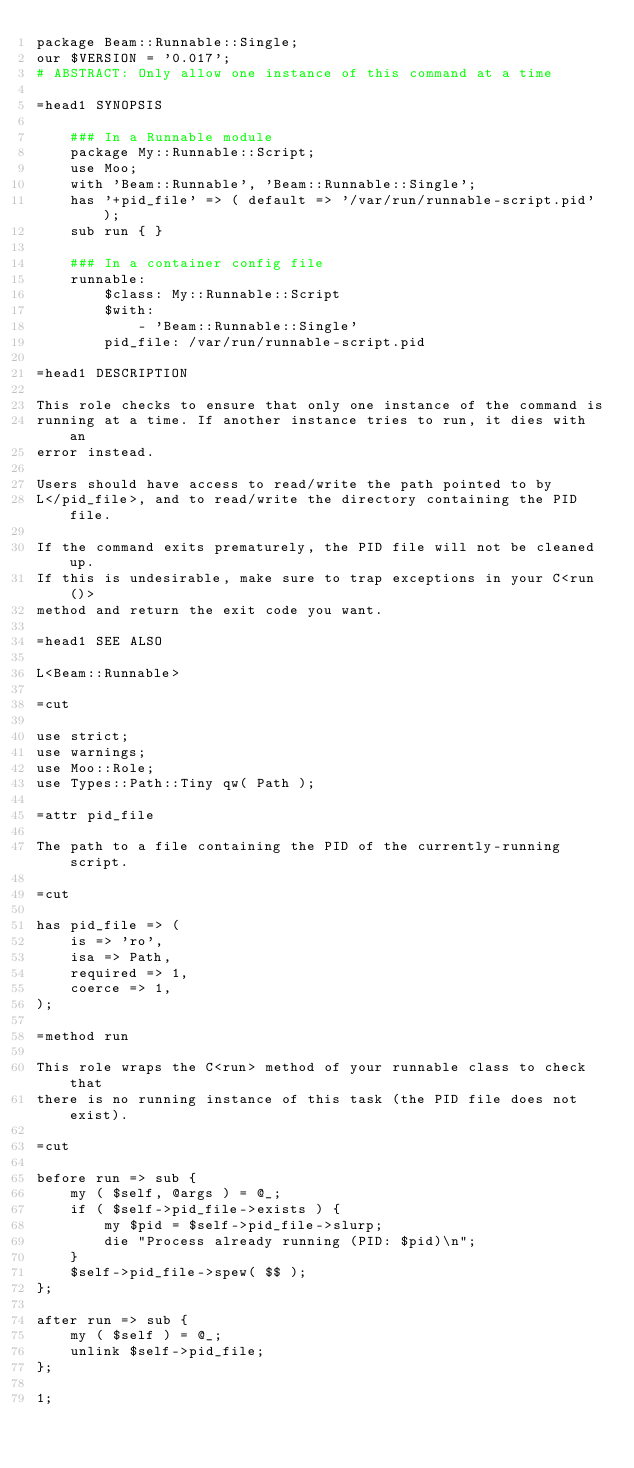Convert code to text. <code><loc_0><loc_0><loc_500><loc_500><_Perl_>package Beam::Runnable::Single;
our $VERSION = '0.017';
# ABSTRACT: Only allow one instance of this command at a time

=head1 SYNOPSIS

    ### In a Runnable module
    package My::Runnable::Script;
    use Moo;
    with 'Beam::Runnable', 'Beam::Runnable::Single';
    has '+pid_file' => ( default => '/var/run/runnable-script.pid' );
    sub run { }

    ### In a container config file
    runnable:
        $class: My::Runnable::Script
        $with:
            - 'Beam::Runnable::Single'
        pid_file: /var/run/runnable-script.pid

=head1 DESCRIPTION

This role checks to ensure that only one instance of the command is
running at a time. If another instance tries to run, it dies with an
error instead.

Users should have access to read/write the path pointed to by
L</pid_file>, and to read/write the directory containing the PID file.

If the command exits prematurely, the PID file will not be cleaned up.
If this is undesirable, make sure to trap exceptions in your C<run()>
method and return the exit code you want.

=head1 SEE ALSO

L<Beam::Runnable>

=cut

use strict;
use warnings;
use Moo::Role;
use Types::Path::Tiny qw( Path );

=attr pid_file

The path to a file containing the PID of the currently-running script.

=cut

has pid_file => (
    is => 'ro',
    isa => Path,
    required => 1,
    coerce => 1,
);

=method run

This role wraps the C<run> method of your runnable class to check that
there is no running instance of this task (the PID file does not exist).

=cut

before run => sub {
    my ( $self, @args ) = @_;
    if ( $self->pid_file->exists ) {
        my $pid = $self->pid_file->slurp;
        die "Process already running (PID: $pid)\n";
    }
    $self->pid_file->spew( $$ );
};

after run => sub {
    my ( $self ) = @_;
    unlink $self->pid_file;
};

1;
</code> 